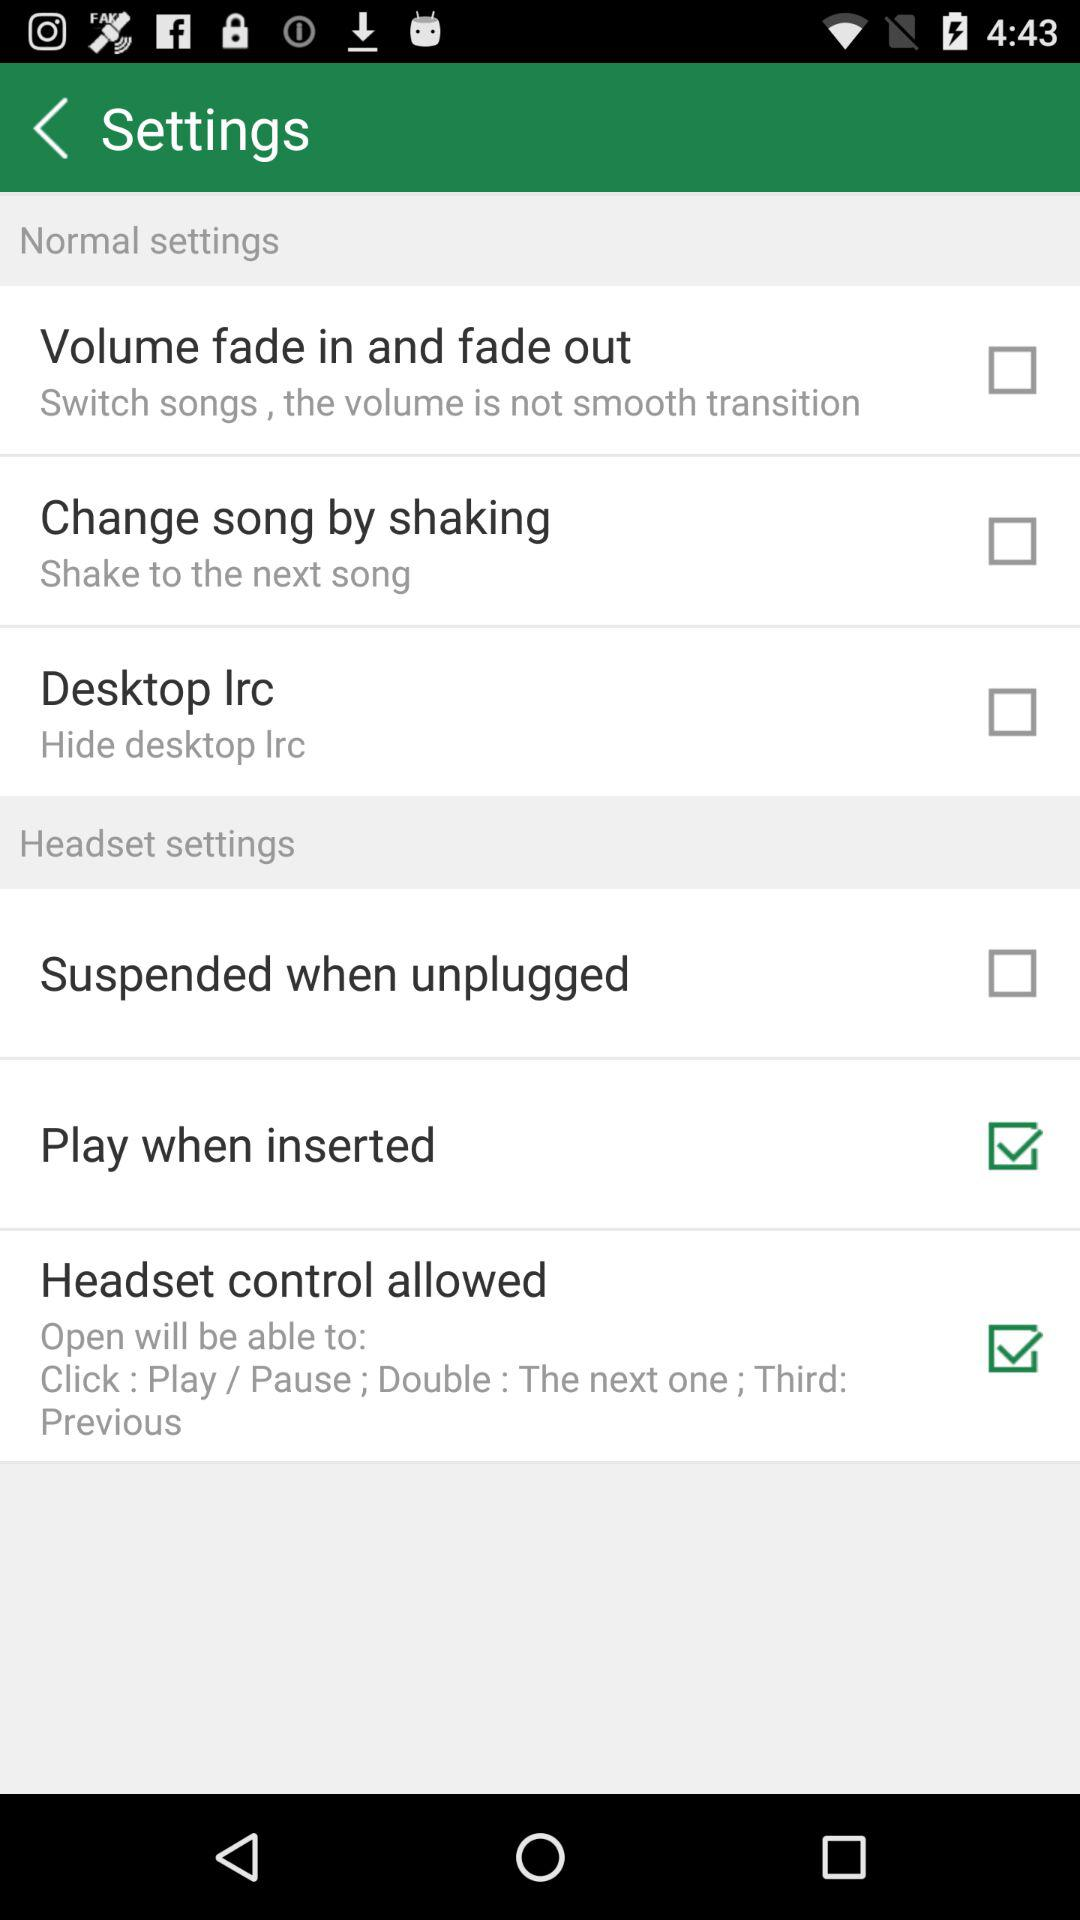Which options are enabled under the headset settings? The options are "Play when inserted" and "Headset control allowed". 